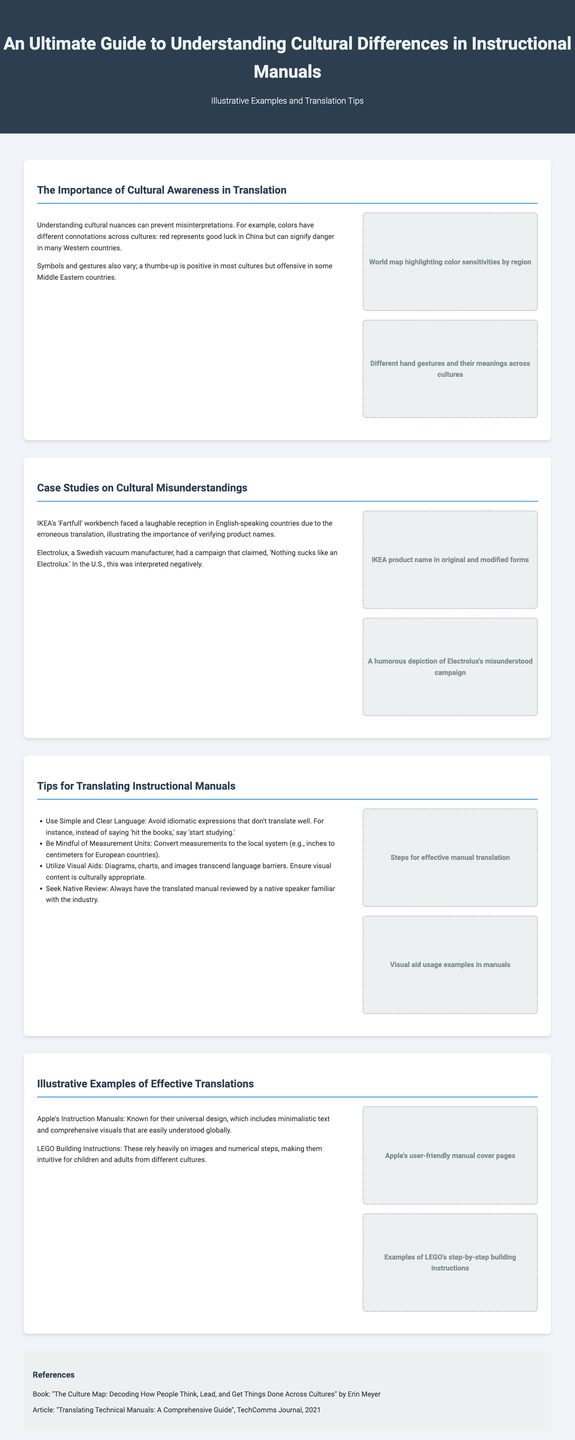What represents good luck in China? In the document, it is stated that red represents good luck in China.
Answer: red What type of campaign did Electrolux use that was interpreted negatively? The text mentions that Electrolux had a campaign claiming "Nothing sucks like an Electrolux," which was interpreted negatively in the U.S.
Answer: humorous campaign Which Swedish company faced issues due to a humorous translation of a product name? The document notes that IKEA's 'Fartfull' workbench received a laughable reception due to the translation.
Answer: IKEA What is the first tip for translating instructional manuals? The first tip mentioned is to use simple and clear language.
Answer: simple and clear language How many case studies on cultural misunderstandings are presented in the document? The document provides two case studies on cultural misunderstandings.
Answer: two What should always be done after translating a manual? It is suggested that the translated manual should always be reviewed by a native speaker.
Answer: native review Which company is known for its universal design in instruction manuals? The document refers to Apple's instruction manuals as known for their universal design.
Answer: Apple What visual aid is recommended for transcending language barriers? Diagrams, charts, and images are emphasized as visual aids that transcend language barriers.
Answer: visual aids 